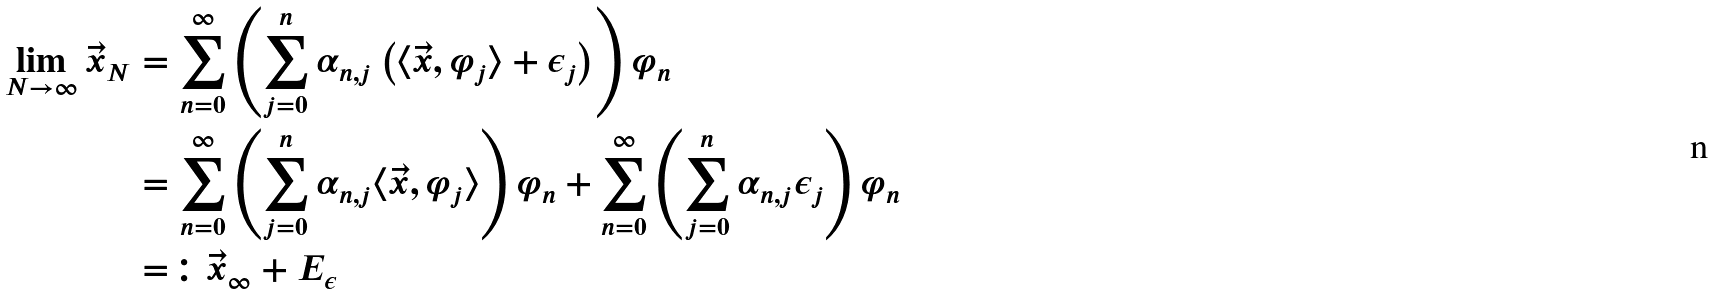<formula> <loc_0><loc_0><loc_500><loc_500>\lim _ { N \to \infty } \vec { x } _ { N } & = \sum _ { n = 0 } ^ { \infty } \left ( \sum _ { j = 0 } ^ { n } \alpha _ { n , j } \left ( \langle \vec { x } , \varphi _ { j } \rangle + \epsilon _ { j } \right ) \right ) \varphi _ { n } \\ & = \sum _ { n = 0 } ^ { \infty } \left ( \sum _ { j = 0 } ^ { n } \alpha _ { n , j } \langle \vec { x } , \varphi _ { j } \rangle \right ) \varphi _ { n } + \sum _ { n = 0 } ^ { \infty } \left ( \sum _ { j = 0 } ^ { n } \alpha _ { n , j } \epsilon _ { j } \right ) \varphi _ { n } \\ & = \colon \vec { x } _ { \infty } + E _ { \epsilon }</formula> 